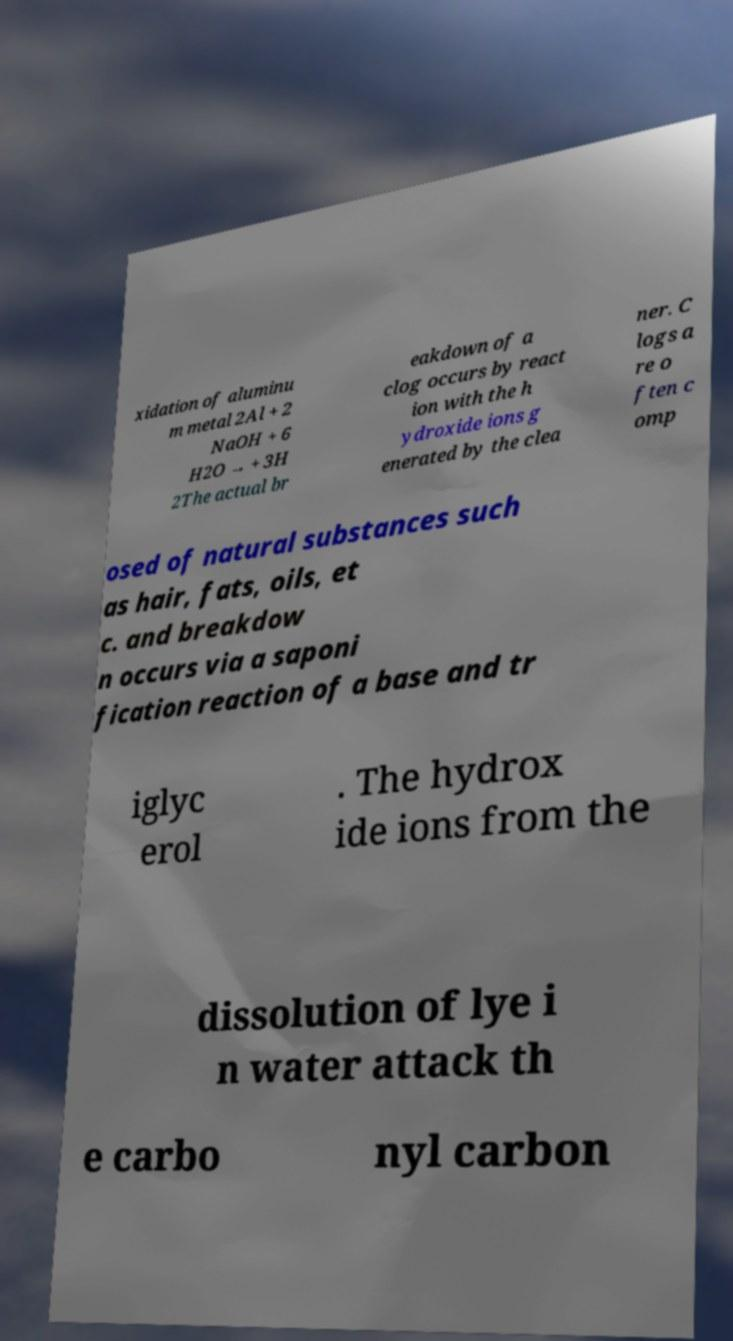Can you accurately transcribe the text from the provided image for me? xidation of aluminu m metal 2Al + 2 NaOH + 6 H2O → + 3H 2The actual br eakdown of a clog occurs by react ion with the h ydroxide ions g enerated by the clea ner. C logs a re o ften c omp osed of natural substances such as hair, fats, oils, et c. and breakdow n occurs via a saponi fication reaction of a base and tr iglyc erol . The hydrox ide ions from the dissolution of lye i n water attack th e carbo nyl carbon 